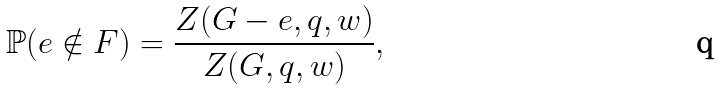Convert formula to latex. <formula><loc_0><loc_0><loc_500><loc_500>\mathbb { P } ( e \notin F ) = \frac { Z ( G - e , q , w ) } { Z ( G , q , w ) } ,</formula> 